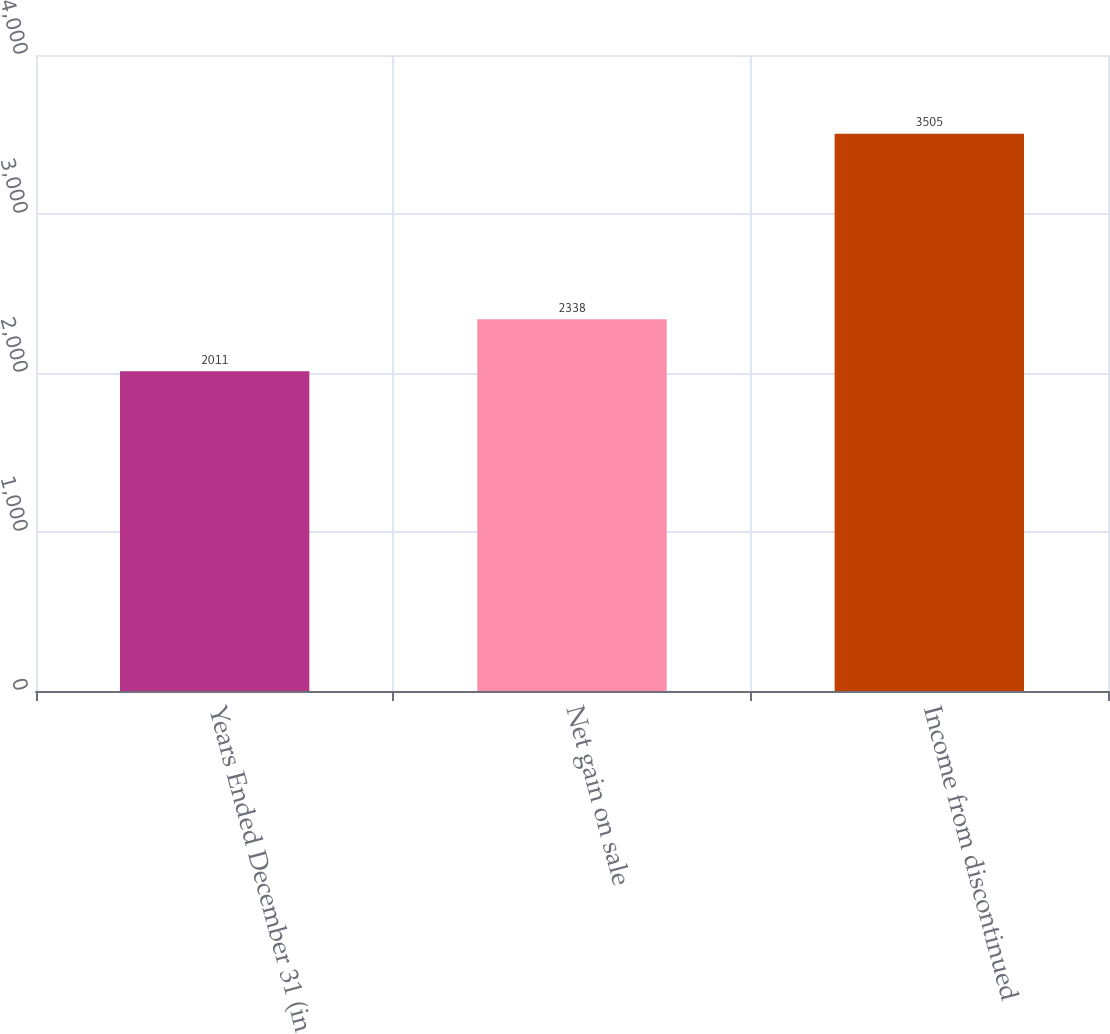Convert chart. <chart><loc_0><loc_0><loc_500><loc_500><bar_chart><fcel>Years Ended December 31 (in<fcel>Net gain on sale<fcel>Income from discontinued<nl><fcel>2011<fcel>2338<fcel>3505<nl></chart> 